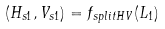Convert formula to latex. <formula><loc_0><loc_0><loc_500><loc_500>( H _ { s 1 } , V _ { s 1 } ) = f _ { s p l i t H V } ( L _ { 1 } )</formula> 